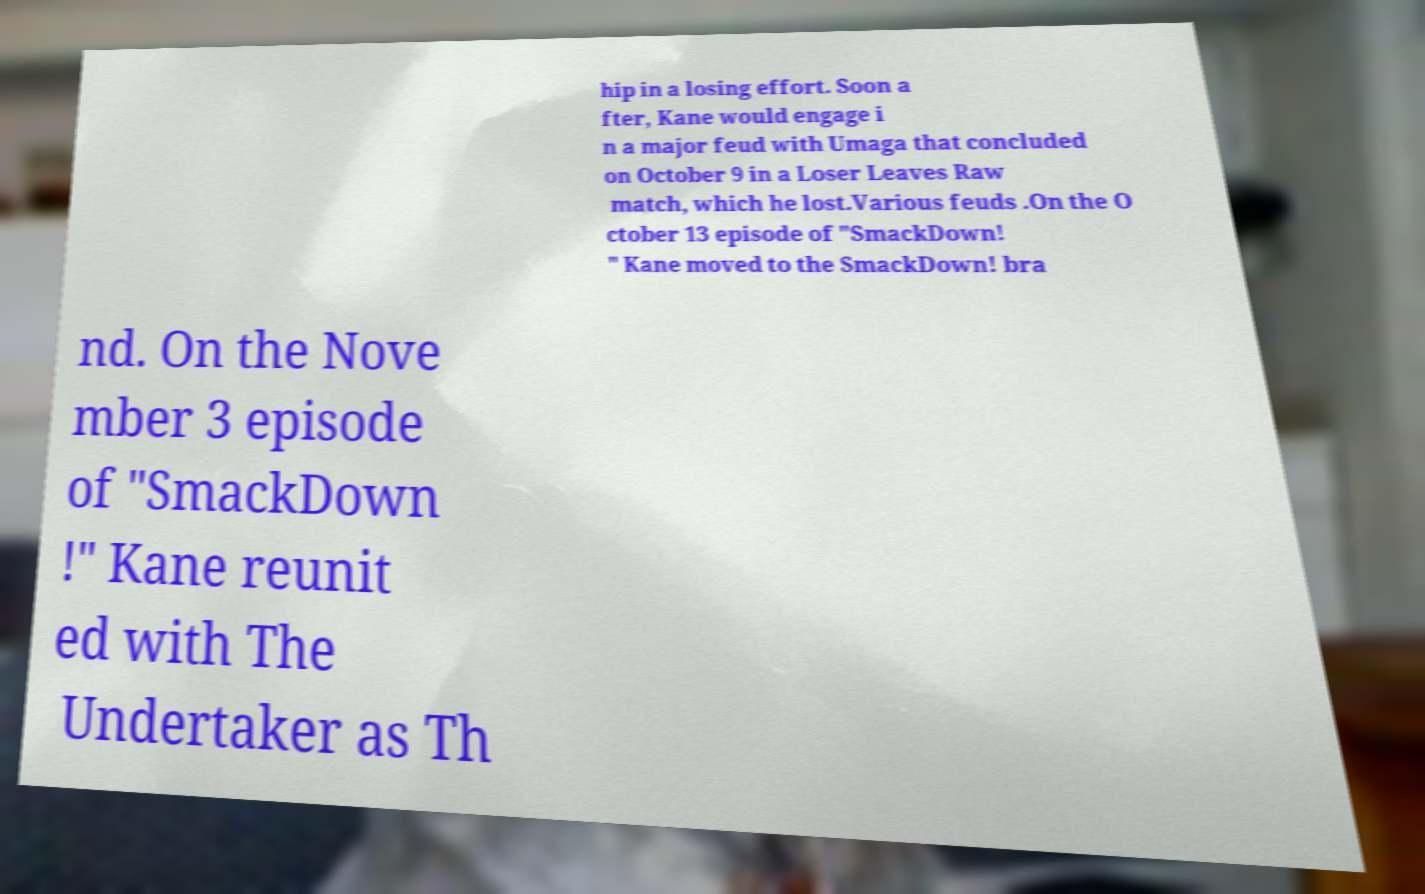Could you extract and type out the text from this image? hip in a losing effort. Soon a fter, Kane would engage i n a major feud with Umaga that concluded on October 9 in a Loser Leaves Raw match, which he lost.Various feuds .On the O ctober 13 episode of "SmackDown! " Kane moved to the SmackDown! bra nd. On the Nove mber 3 episode of "SmackDown !" Kane reunit ed with The Undertaker as Th 